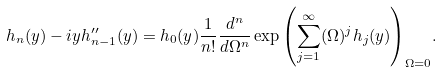Convert formula to latex. <formula><loc_0><loc_0><loc_500><loc_500>h _ { n } ( y ) - i y h ^ { \prime \prime } _ { n - 1 } ( y ) = h _ { 0 } ( y ) \frac { 1 } { n ! } \frac { d ^ { n } } { d \Omega ^ { n } } \exp { \left ( \sum _ { j = 1 } ^ { \infty } ( \Omega ) ^ { j } h _ { j } ( y ) \right ) } _ { \Omega = 0 } .</formula> 